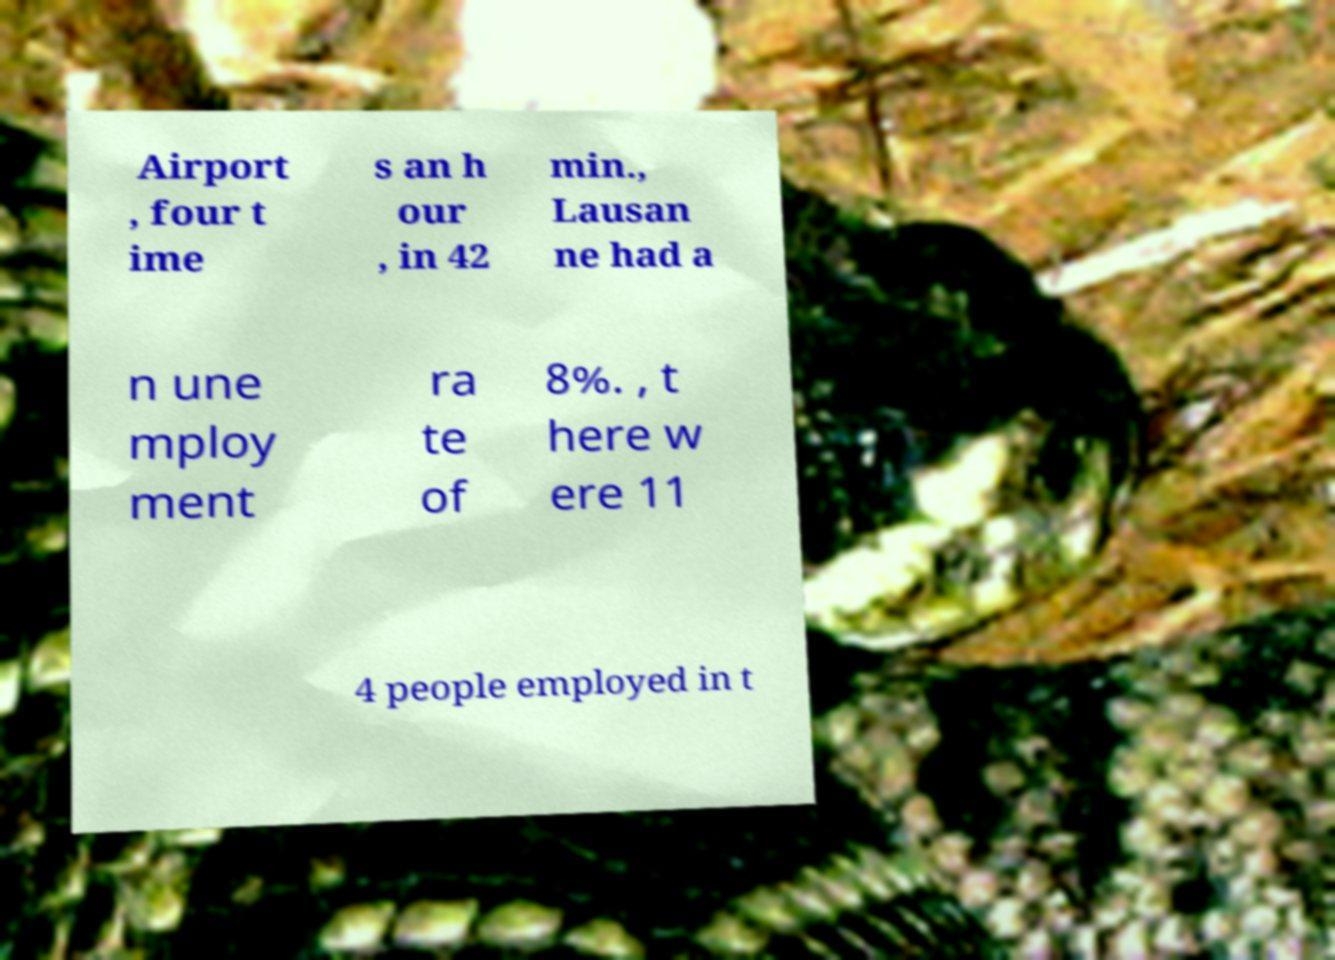Could you assist in decoding the text presented in this image and type it out clearly? Airport , four t ime s an h our , in 42 min., Lausan ne had a n une mploy ment ra te of 8%. , t here w ere 11 4 people employed in t 